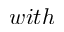Convert formula to latex. <formula><loc_0><loc_0><loc_500><loc_500>w i t h</formula> 